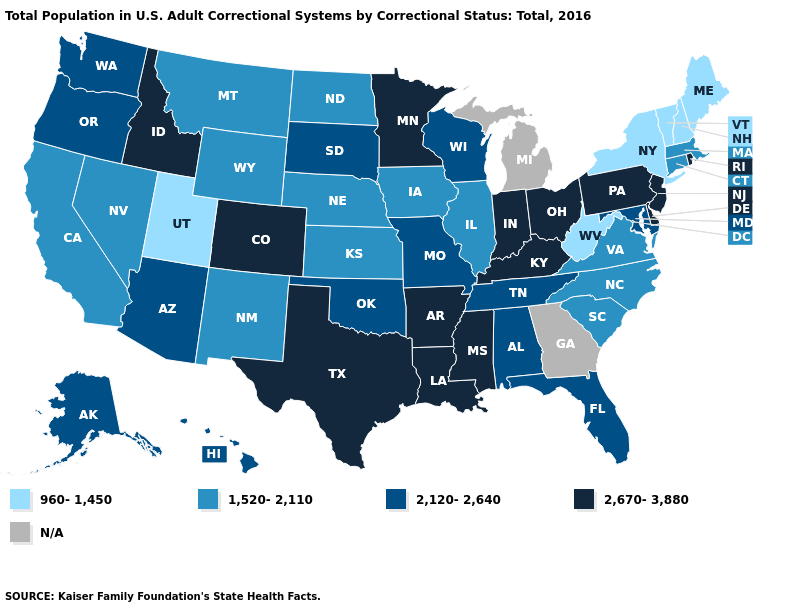Name the states that have a value in the range 960-1,450?
Answer briefly. Maine, New Hampshire, New York, Utah, Vermont, West Virginia. Among the states that border Georgia , does North Carolina have the highest value?
Be succinct. No. What is the value of Pennsylvania?
Be succinct. 2,670-3,880. Name the states that have a value in the range 2,120-2,640?
Short answer required. Alabama, Alaska, Arizona, Florida, Hawaii, Maryland, Missouri, Oklahoma, Oregon, South Dakota, Tennessee, Washington, Wisconsin. Which states have the lowest value in the South?
Give a very brief answer. West Virginia. Which states hav the highest value in the MidWest?
Concise answer only. Indiana, Minnesota, Ohio. Name the states that have a value in the range 1,520-2,110?
Be succinct. California, Connecticut, Illinois, Iowa, Kansas, Massachusetts, Montana, Nebraska, Nevada, New Mexico, North Carolina, North Dakota, South Carolina, Virginia, Wyoming. Which states have the lowest value in the USA?
Answer briefly. Maine, New Hampshire, New York, Utah, Vermont, West Virginia. What is the value of Oregon?
Give a very brief answer. 2,120-2,640. Does California have the highest value in the USA?
Short answer required. No. What is the value of New Jersey?
Quick response, please. 2,670-3,880. Among the states that border Indiana , which have the lowest value?
Answer briefly. Illinois. What is the value of Louisiana?
Be succinct. 2,670-3,880. Does the first symbol in the legend represent the smallest category?
Keep it brief. Yes. 